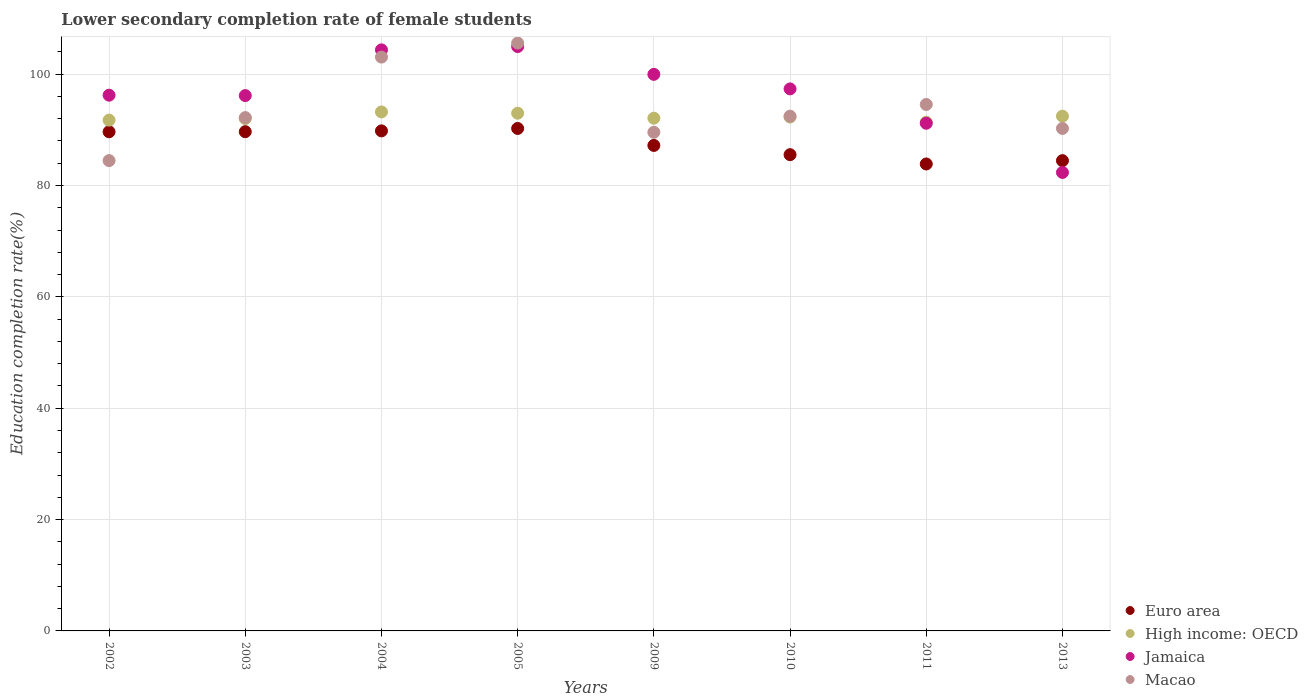How many different coloured dotlines are there?
Your response must be concise. 4. Is the number of dotlines equal to the number of legend labels?
Ensure brevity in your answer.  Yes. What is the lower secondary completion rate of female students in Macao in 2004?
Offer a very short reply. 103.06. Across all years, what is the maximum lower secondary completion rate of female students in Euro area?
Your response must be concise. 90.25. Across all years, what is the minimum lower secondary completion rate of female students in High income: OECD?
Your response must be concise. 91.37. In which year was the lower secondary completion rate of female students in Euro area minimum?
Offer a terse response. 2011. What is the total lower secondary completion rate of female students in High income: OECD in the graph?
Your answer should be very brief. 738.16. What is the difference between the lower secondary completion rate of female students in High income: OECD in 2003 and that in 2009?
Give a very brief answer. -0.07. What is the difference between the lower secondary completion rate of female students in Macao in 2003 and the lower secondary completion rate of female students in Euro area in 2005?
Your response must be concise. 1.95. What is the average lower secondary completion rate of female students in Macao per year?
Give a very brief answer. 94.01. In the year 2005, what is the difference between the lower secondary completion rate of female students in Jamaica and lower secondary completion rate of female students in High income: OECD?
Make the answer very short. 11.97. In how many years, is the lower secondary completion rate of female students in Macao greater than 64 %?
Offer a very short reply. 8. What is the ratio of the lower secondary completion rate of female students in Macao in 2002 to that in 2013?
Your answer should be very brief. 0.94. Is the lower secondary completion rate of female students in Macao in 2002 less than that in 2013?
Your answer should be compact. Yes. What is the difference between the highest and the second highest lower secondary completion rate of female students in Euro area?
Keep it short and to the point. 0.44. What is the difference between the highest and the lowest lower secondary completion rate of female students in Macao?
Ensure brevity in your answer.  21.11. In how many years, is the lower secondary completion rate of female students in Jamaica greater than the average lower secondary completion rate of female students in Jamaica taken over all years?
Make the answer very short. 4. Does the lower secondary completion rate of female students in High income: OECD monotonically increase over the years?
Offer a terse response. No. Is the lower secondary completion rate of female students in Euro area strictly less than the lower secondary completion rate of female students in Jamaica over the years?
Provide a short and direct response. No. What is the difference between two consecutive major ticks on the Y-axis?
Offer a very short reply. 20. Does the graph contain grids?
Give a very brief answer. Yes. What is the title of the graph?
Keep it short and to the point. Lower secondary completion rate of female students. Does "Argentina" appear as one of the legend labels in the graph?
Provide a short and direct response. No. What is the label or title of the X-axis?
Ensure brevity in your answer.  Years. What is the label or title of the Y-axis?
Give a very brief answer. Education completion rate(%). What is the Education completion rate(%) of Euro area in 2002?
Your response must be concise. 89.65. What is the Education completion rate(%) in High income: OECD in 2002?
Give a very brief answer. 91.74. What is the Education completion rate(%) of Jamaica in 2002?
Give a very brief answer. 96.22. What is the Education completion rate(%) in Macao in 2002?
Provide a short and direct response. 84.47. What is the Education completion rate(%) in Euro area in 2003?
Provide a succinct answer. 89.66. What is the Education completion rate(%) of High income: OECD in 2003?
Provide a short and direct response. 92.02. What is the Education completion rate(%) in Jamaica in 2003?
Offer a very short reply. 96.15. What is the Education completion rate(%) of Macao in 2003?
Make the answer very short. 92.19. What is the Education completion rate(%) in Euro area in 2004?
Your answer should be compact. 89.81. What is the Education completion rate(%) of High income: OECD in 2004?
Provide a short and direct response. 93.21. What is the Education completion rate(%) of Jamaica in 2004?
Your response must be concise. 104.36. What is the Education completion rate(%) of Macao in 2004?
Make the answer very short. 103.06. What is the Education completion rate(%) in Euro area in 2005?
Give a very brief answer. 90.25. What is the Education completion rate(%) of High income: OECD in 2005?
Keep it short and to the point. 92.98. What is the Education completion rate(%) of Jamaica in 2005?
Make the answer very short. 104.95. What is the Education completion rate(%) of Macao in 2005?
Your answer should be compact. 105.58. What is the Education completion rate(%) of Euro area in 2009?
Provide a succinct answer. 87.19. What is the Education completion rate(%) of High income: OECD in 2009?
Your answer should be very brief. 92.09. What is the Education completion rate(%) in Jamaica in 2009?
Make the answer very short. 99.96. What is the Education completion rate(%) of Macao in 2009?
Provide a short and direct response. 89.55. What is the Education completion rate(%) in Euro area in 2010?
Your answer should be very brief. 85.53. What is the Education completion rate(%) of High income: OECD in 2010?
Your response must be concise. 92.29. What is the Education completion rate(%) in Jamaica in 2010?
Your answer should be compact. 97.35. What is the Education completion rate(%) in Macao in 2010?
Your response must be concise. 92.45. What is the Education completion rate(%) in Euro area in 2011?
Your response must be concise. 83.87. What is the Education completion rate(%) of High income: OECD in 2011?
Your answer should be compact. 91.37. What is the Education completion rate(%) of Jamaica in 2011?
Give a very brief answer. 91.18. What is the Education completion rate(%) of Macao in 2011?
Your answer should be very brief. 94.55. What is the Education completion rate(%) in Euro area in 2013?
Your answer should be compact. 84.46. What is the Education completion rate(%) of High income: OECD in 2013?
Offer a very short reply. 92.45. What is the Education completion rate(%) of Jamaica in 2013?
Provide a succinct answer. 82.34. What is the Education completion rate(%) of Macao in 2013?
Offer a very short reply. 90.25. Across all years, what is the maximum Education completion rate(%) in Euro area?
Your response must be concise. 90.25. Across all years, what is the maximum Education completion rate(%) of High income: OECD?
Make the answer very short. 93.21. Across all years, what is the maximum Education completion rate(%) in Jamaica?
Make the answer very short. 104.95. Across all years, what is the maximum Education completion rate(%) in Macao?
Your response must be concise. 105.58. Across all years, what is the minimum Education completion rate(%) in Euro area?
Provide a short and direct response. 83.87. Across all years, what is the minimum Education completion rate(%) of High income: OECD?
Keep it short and to the point. 91.37. Across all years, what is the minimum Education completion rate(%) in Jamaica?
Your answer should be compact. 82.34. Across all years, what is the minimum Education completion rate(%) in Macao?
Make the answer very short. 84.47. What is the total Education completion rate(%) in Euro area in the graph?
Offer a terse response. 700.42. What is the total Education completion rate(%) of High income: OECD in the graph?
Offer a very short reply. 738.16. What is the total Education completion rate(%) in Jamaica in the graph?
Provide a succinct answer. 772.5. What is the total Education completion rate(%) of Macao in the graph?
Provide a short and direct response. 752.12. What is the difference between the Education completion rate(%) of Euro area in 2002 and that in 2003?
Ensure brevity in your answer.  -0.02. What is the difference between the Education completion rate(%) of High income: OECD in 2002 and that in 2003?
Offer a terse response. -0.28. What is the difference between the Education completion rate(%) in Jamaica in 2002 and that in 2003?
Offer a very short reply. 0.07. What is the difference between the Education completion rate(%) of Macao in 2002 and that in 2003?
Your answer should be very brief. -7.72. What is the difference between the Education completion rate(%) in Euro area in 2002 and that in 2004?
Make the answer very short. -0.16. What is the difference between the Education completion rate(%) of High income: OECD in 2002 and that in 2004?
Offer a very short reply. -1.47. What is the difference between the Education completion rate(%) in Jamaica in 2002 and that in 2004?
Your response must be concise. -8.14. What is the difference between the Education completion rate(%) of Macao in 2002 and that in 2004?
Ensure brevity in your answer.  -18.59. What is the difference between the Education completion rate(%) of Euro area in 2002 and that in 2005?
Your response must be concise. -0.6. What is the difference between the Education completion rate(%) in High income: OECD in 2002 and that in 2005?
Make the answer very short. -1.24. What is the difference between the Education completion rate(%) in Jamaica in 2002 and that in 2005?
Keep it short and to the point. -8.73. What is the difference between the Education completion rate(%) of Macao in 2002 and that in 2005?
Make the answer very short. -21.11. What is the difference between the Education completion rate(%) of Euro area in 2002 and that in 2009?
Give a very brief answer. 2.45. What is the difference between the Education completion rate(%) in High income: OECD in 2002 and that in 2009?
Offer a very short reply. -0.35. What is the difference between the Education completion rate(%) of Jamaica in 2002 and that in 2009?
Your response must be concise. -3.74. What is the difference between the Education completion rate(%) in Macao in 2002 and that in 2009?
Offer a very short reply. -5.08. What is the difference between the Education completion rate(%) of Euro area in 2002 and that in 2010?
Keep it short and to the point. 4.11. What is the difference between the Education completion rate(%) in High income: OECD in 2002 and that in 2010?
Ensure brevity in your answer.  -0.55. What is the difference between the Education completion rate(%) in Jamaica in 2002 and that in 2010?
Provide a succinct answer. -1.13. What is the difference between the Education completion rate(%) of Macao in 2002 and that in 2010?
Ensure brevity in your answer.  -7.98. What is the difference between the Education completion rate(%) in Euro area in 2002 and that in 2011?
Offer a terse response. 5.78. What is the difference between the Education completion rate(%) of High income: OECD in 2002 and that in 2011?
Your response must be concise. 0.37. What is the difference between the Education completion rate(%) in Jamaica in 2002 and that in 2011?
Your answer should be compact. 5.04. What is the difference between the Education completion rate(%) in Macao in 2002 and that in 2011?
Keep it short and to the point. -10.08. What is the difference between the Education completion rate(%) in Euro area in 2002 and that in 2013?
Provide a short and direct response. 5.19. What is the difference between the Education completion rate(%) of High income: OECD in 2002 and that in 2013?
Provide a succinct answer. -0.71. What is the difference between the Education completion rate(%) in Jamaica in 2002 and that in 2013?
Keep it short and to the point. 13.88. What is the difference between the Education completion rate(%) of Macao in 2002 and that in 2013?
Provide a succinct answer. -5.78. What is the difference between the Education completion rate(%) of Euro area in 2003 and that in 2004?
Offer a terse response. -0.14. What is the difference between the Education completion rate(%) in High income: OECD in 2003 and that in 2004?
Provide a short and direct response. -1.19. What is the difference between the Education completion rate(%) in Jamaica in 2003 and that in 2004?
Your answer should be compact. -8.21. What is the difference between the Education completion rate(%) of Macao in 2003 and that in 2004?
Offer a very short reply. -10.87. What is the difference between the Education completion rate(%) in Euro area in 2003 and that in 2005?
Give a very brief answer. -0.58. What is the difference between the Education completion rate(%) of High income: OECD in 2003 and that in 2005?
Ensure brevity in your answer.  -0.96. What is the difference between the Education completion rate(%) in Jamaica in 2003 and that in 2005?
Give a very brief answer. -8.8. What is the difference between the Education completion rate(%) in Macao in 2003 and that in 2005?
Ensure brevity in your answer.  -13.39. What is the difference between the Education completion rate(%) in Euro area in 2003 and that in 2009?
Your response must be concise. 2.47. What is the difference between the Education completion rate(%) in High income: OECD in 2003 and that in 2009?
Offer a terse response. -0.07. What is the difference between the Education completion rate(%) in Jamaica in 2003 and that in 2009?
Your answer should be compact. -3.81. What is the difference between the Education completion rate(%) of Macao in 2003 and that in 2009?
Ensure brevity in your answer.  2.64. What is the difference between the Education completion rate(%) in Euro area in 2003 and that in 2010?
Ensure brevity in your answer.  4.13. What is the difference between the Education completion rate(%) of High income: OECD in 2003 and that in 2010?
Provide a short and direct response. -0.27. What is the difference between the Education completion rate(%) of Jamaica in 2003 and that in 2010?
Provide a short and direct response. -1.2. What is the difference between the Education completion rate(%) in Macao in 2003 and that in 2010?
Give a very brief answer. -0.26. What is the difference between the Education completion rate(%) of Euro area in 2003 and that in 2011?
Your response must be concise. 5.8. What is the difference between the Education completion rate(%) of High income: OECD in 2003 and that in 2011?
Offer a very short reply. 0.65. What is the difference between the Education completion rate(%) in Jamaica in 2003 and that in 2011?
Your answer should be very brief. 4.97. What is the difference between the Education completion rate(%) of Macao in 2003 and that in 2011?
Your answer should be compact. -2.36. What is the difference between the Education completion rate(%) in Euro area in 2003 and that in 2013?
Provide a short and direct response. 5.2. What is the difference between the Education completion rate(%) in High income: OECD in 2003 and that in 2013?
Offer a very short reply. -0.43. What is the difference between the Education completion rate(%) of Jamaica in 2003 and that in 2013?
Provide a short and direct response. 13.8. What is the difference between the Education completion rate(%) in Macao in 2003 and that in 2013?
Provide a succinct answer. 1.95. What is the difference between the Education completion rate(%) in Euro area in 2004 and that in 2005?
Your answer should be very brief. -0.44. What is the difference between the Education completion rate(%) in High income: OECD in 2004 and that in 2005?
Your answer should be compact. 0.23. What is the difference between the Education completion rate(%) of Jamaica in 2004 and that in 2005?
Provide a succinct answer. -0.59. What is the difference between the Education completion rate(%) of Macao in 2004 and that in 2005?
Keep it short and to the point. -2.52. What is the difference between the Education completion rate(%) of Euro area in 2004 and that in 2009?
Offer a terse response. 2.61. What is the difference between the Education completion rate(%) in High income: OECD in 2004 and that in 2009?
Your answer should be very brief. 1.13. What is the difference between the Education completion rate(%) of Jamaica in 2004 and that in 2009?
Your answer should be compact. 4.4. What is the difference between the Education completion rate(%) of Macao in 2004 and that in 2009?
Your answer should be very brief. 13.51. What is the difference between the Education completion rate(%) of Euro area in 2004 and that in 2010?
Provide a short and direct response. 4.27. What is the difference between the Education completion rate(%) of High income: OECD in 2004 and that in 2010?
Ensure brevity in your answer.  0.92. What is the difference between the Education completion rate(%) of Jamaica in 2004 and that in 2010?
Your answer should be very brief. 7.01. What is the difference between the Education completion rate(%) in Macao in 2004 and that in 2010?
Your answer should be compact. 10.61. What is the difference between the Education completion rate(%) in Euro area in 2004 and that in 2011?
Offer a very short reply. 5.94. What is the difference between the Education completion rate(%) in High income: OECD in 2004 and that in 2011?
Ensure brevity in your answer.  1.84. What is the difference between the Education completion rate(%) of Jamaica in 2004 and that in 2011?
Offer a terse response. 13.18. What is the difference between the Education completion rate(%) in Macao in 2004 and that in 2011?
Offer a terse response. 8.51. What is the difference between the Education completion rate(%) in Euro area in 2004 and that in 2013?
Make the answer very short. 5.35. What is the difference between the Education completion rate(%) of High income: OECD in 2004 and that in 2013?
Your answer should be compact. 0.76. What is the difference between the Education completion rate(%) of Jamaica in 2004 and that in 2013?
Your answer should be compact. 22.01. What is the difference between the Education completion rate(%) in Macao in 2004 and that in 2013?
Provide a short and direct response. 12.82. What is the difference between the Education completion rate(%) of Euro area in 2005 and that in 2009?
Give a very brief answer. 3.05. What is the difference between the Education completion rate(%) in High income: OECD in 2005 and that in 2009?
Provide a succinct answer. 0.9. What is the difference between the Education completion rate(%) in Jamaica in 2005 and that in 2009?
Offer a terse response. 4.99. What is the difference between the Education completion rate(%) of Macao in 2005 and that in 2009?
Make the answer very short. 16.03. What is the difference between the Education completion rate(%) of Euro area in 2005 and that in 2010?
Offer a terse response. 4.71. What is the difference between the Education completion rate(%) of High income: OECD in 2005 and that in 2010?
Make the answer very short. 0.69. What is the difference between the Education completion rate(%) in Jamaica in 2005 and that in 2010?
Provide a succinct answer. 7.6. What is the difference between the Education completion rate(%) of Macao in 2005 and that in 2010?
Your answer should be very brief. 13.13. What is the difference between the Education completion rate(%) of Euro area in 2005 and that in 2011?
Ensure brevity in your answer.  6.38. What is the difference between the Education completion rate(%) in High income: OECD in 2005 and that in 2011?
Your answer should be compact. 1.61. What is the difference between the Education completion rate(%) in Jamaica in 2005 and that in 2011?
Keep it short and to the point. 13.77. What is the difference between the Education completion rate(%) in Macao in 2005 and that in 2011?
Ensure brevity in your answer.  11.03. What is the difference between the Education completion rate(%) in Euro area in 2005 and that in 2013?
Provide a succinct answer. 5.78. What is the difference between the Education completion rate(%) of High income: OECD in 2005 and that in 2013?
Provide a short and direct response. 0.53. What is the difference between the Education completion rate(%) in Jamaica in 2005 and that in 2013?
Keep it short and to the point. 22.61. What is the difference between the Education completion rate(%) of Macao in 2005 and that in 2013?
Ensure brevity in your answer.  15.34. What is the difference between the Education completion rate(%) in Euro area in 2009 and that in 2010?
Your answer should be compact. 1.66. What is the difference between the Education completion rate(%) in High income: OECD in 2009 and that in 2010?
Provide a succinct answer. -0.21. What is the difference between the Education completion rate(%) of Jamaica in 2009 and that in 2010?
Offer a very short reply. 2.61. What is the difference between the Education completion rate(%) in Macao in 2009 and that in 2010?
Ensure brevity in your answer.  -2.9. What is the difference between the Education completion rate(%) in Euro area in 2009 and that in 2011?
Offer a very short reply. 3.33. What is the difference between the Education completion rate(%) in High income: OECD in 2009 and that in 2011?
Make the answer very short. 0.72. What is the difference between the Education completion rate(%) of Jamaica in 2009 and that in 2011?
Provide a succinct answer. 8.78. What is the difference between the Education completion rate(%) of Macao in 2009 and that in 2011?
Your answer should be compact. -5. What is the difference between the Education completion rate(%) of Euro area in 2009 and that in 2013?
Your response must be concise. 2.73. What is the difference between the Education completion rate(%) of High income: OECD in 2009 and that in 2013?
Ensure brevity in your answer.  -0.36. What is the difference between the Education completion rate(%) in Jamaica in 2009 and that in 2013?
Your answer should be compact. 17.62. What is the difference between the Education completion rate(%) of Macao in 2009 and that in 2013?
Provide a short and direct response. -0.69. What is the difference between the Education completion rate(%) of Euro area in 2010 and that in 2011?
Ensure brevity in your answer.  1.67. What is the difference between the Education completion rate(%) of High income: OECD in 2010 and that in 2011?
Your response must be concise. 0.92. What is the difference between the Education completion rate(%) in Jamaica in 2010 and that in 2011?
Provide a short and direct response. 6.17. What is the difference between the Education completion rate(%) in Macao in 2010 and that in 2011?
Offer a very short reply. -2.1. What is the difference between the Education completion rate(%) in Euro area in 2010 and that in 2013?
Keep it short and to the point. 1.07. What is the difference between the Education completion rate(%) of High income: OECD in 2010 and that in 2013?
Offer a terse response. -0.16. What is the difference between the Education completion rate(%) in Jamaica in 2010 and that in 2013?
Your response must be concise. 15.01. What is the difference between the Education completion rate(%) in Macao in 2010 and that in 2013?
Offer a terse response. 2.21. What is the difference between the Education completion rate(%) of Euro area in 2011 and that in 2013?
Your response must be concise. -0.6. What is the difference between the Education completion rate(%) of High income: OECD in 2011 and that in 2013?
Ensure brevity in your answer.  -1.08. What is the difference between the Education completion rate(%) of Jamaica in 2011 and that in 2013?
Your answer should be very brief. 8.83. What is the difference between the Education completion rate(%) in Macao in 2011 and that in 2013?
Ensure brevity in your answer.  4.31. What is the difference between the Education completion rate(%) in Euro area in 2002 and the Education completion rate(%) in High income: OECD in 2003?
Offer a very short reply. -2.37. What is the difference between the Education completion rate(%) of Euro area in 2002 and the Education completion rate(%) of Jamaica in 2003?
Ensure brevity in your answer.  -6.5. What is the difference between the Education completion rate(%) of Euro area in 2002 and the Education completion rate(%) of Macao in 2003?
Keep it short and to the point. -2.55. What is the difference between the Education completion rate(%) of High income: OECD in 2002 and the Education completion rate(%) of Jamaica in 2003?
Your answer should be very brief. -4.41. What is the difference between the Education completion rate(%) in High income: OECD in 2002 and the Education completion rate(%) in Macao in 2003?
Offer a terse response. -0.45. What is the difference between the Education completion rate(%) in Jamaica in 2002 and the Education completion rate(%) in Macao in 2003?
Your answer should be compact. 4.02. What is the difference between the Education completion rate(%) of Euro area in 2002 and the Education completion rate(%) of High income: OECD in 2004?
Ensure brevity in your answer.  -3.57. What is the difference between the Education completion rate(%) of Euro area in 2002 and the Education completion rate(%) of Jamaica in 2004?
Provide a succinct answer. -14.71. What is the difference between the Education completion rate(%) in Euro area in 2002 and the Education completion rate(%) in Macao in 2004?
Your answer should be compact. -13.41. What is the difference between the Education completion rate(%) in High income: OECD in 2002 and the Education completion rate(%) in Jamaica in 2004?
Provide a short and direct response. -12.62. What is the difference between the Education completion rate(%) in High income: OECD in 2002 and the Education completion rate(%) in Macao in 2004?
Your answer should be compact. -11.32. What is the difference between the Education completion rate(%) of Jamaica in 2002 and the Education completion rate(%) of Macao in 2004?
Provide a short and direct response. -6.84. What is the difference between the Education completion rate(%) of Euro area in 2002 and the Education completion rate(%) of High income: OECD in 2005?
Ensure brevity in your answer.  -3.34. What is the difference between the Education completion rate(%) in Euro area in 2002 and the Education completion rate(%) in Jamaica in 2005?
Your answer should be very brief. -15.3. What is the difference between the Education completion rate(%) of Euro area in 2002 and the Education completion rate(%) of Macao in 2005?
Make the answer very short. -15.94. What is the difference between the Education completion rate(%) of High income: OECD in 2002 and the Education completion rate(%) of Jamaica in 2005?
Your answer should be compact. -13.21. What is the difference between the Education completion rate(%) in High income: OECD in 2002 and the Education completion rate(%) in Macao in 2005?
Your response must be concise. -13.84. What is the difference between the Education completion rate(%) in Jamaica in 2002 and the Education completion rate(%) in Macao in 2005?
Make the answer very short. -9.37. What is the difference between the Education completion rate(%) in Euro area in 2002 and the Education completion rate(%) in High income: OECD in 2009?
Your response must be concise. -2.44. What is the difference between the Education completion rate(%) in Euro area in 2002 and the Education completion rate(%) in Jamaica in 2009?
Offer a terse response. -10.31. What is the difference between the Education completion rate(%) of Euro area in 2002 and the Education completion rate(%) of Macao in 2009?
Your response must be concise. 0.09. What is the difference between the Education completion rate(%) of High income: OECD in 2002 and the Education completion rate(%) of Jamaica in 2009?
Keep it short and to the point. -8.22. What is the difference between the Education completion rate(%) in High income: OECD in 2002 and the Education completion rate(%) in Macao in 2009?
Ensure brevity in your answer.  2.19. What is the difference between the Education completion rate(%) in Jamaica in 2002 and the Education completion rate(%) in Macao in 2009?
Offer a terse response. 6.66. What is the difference between the Education completion rate(%) of Euro area in 2002 and the Education completion rate(%) of High income: OECD in 2010?
Provide a short and direct response. -2.65. What is the difference between the Education completion rate(%) in Euro area in 2002 and the Education completion rate(%) in Jamaica in 2010?
Ensure brevity in your answer.  -7.7. What is the difference between the Education completion rate(%) in Euro area in 2002 and the Education completion rate(%) in Macao in 2010?
Your response must be concise. -2.81. What is the difference between the Education completion rate(%) of High income: OECD in 2002 and the Education completion rate(%) of Jamaica in 2010?
Your answer should be compact. -5.61. What is the difference between the Education completion rate(%) of High income: OECD in 2002 and the Education completion rate(%) of Macao in 2010?
Ensure brevity in your answer.  -0.71. What is the difference between the Education completion rate(%) in Jamaica in 2002 and the Education completion rate(%) in Macao in 2010?
Offer a very short reply. 3.77. What is the difference between the Education completion rate(%) in Euro area in 2002 and the Education completion rate(%) in High income: OECD in 2011?
Provide a short and direct response. -1.72. What is the difference between the Education completion rate(%) of Euro area in 2002 and the Education completion rate(%) of Jamaica in 2011?
Your answer should be very brief. -1.53. What is the difference between the Education completion rate(%) of Euro area in 2002 and the Education completion rate(%) of Macao in 2011?
Provide a short and direct response. -4.9. What is the difference between the Education completion rate(%) in High income: OECD in 2002 and the Education completion rate(%) in Jamaica in 2011?
Provide a succinct answer. 0.56. What is the difference between the Education completion rate(%) in High income: OECD in 2002 and the Education completion rate(%) in Macao in 2011?
Your response must be concise. -2.81. What is the difference between the Education completion rate(%) of Jamaica in 2002 and the Education completion rate(%) of Macao in 2011?
Provide a short and direct response. 1.67. What is the difference between the Education completion rate(%) in Euro area in 2002 and the Education completion rate(%) in High income: OECD in 2013?
Provide a succinct answer. -2.8. What is the difference between the Education completion rate(%) in Euro area in 2002 and the Education completion rate(%) in Jamaica in 2013?
Offer a terse response. 7.3. What is the difference between the Education completion rate(%) in Euro area in 2002 and the Education completion rate(%) in Macao in 2013?
Give a very brief answer. -0.6. What is the difference between the Education completion rate(%) of High income: OECD in 2002 and the Education completion rate(%) of Jamaica in 2013?
Make the answer very short. 9.4. What is the difference between the Education completion rate(%) of High income: OECD in 2002 and the Education completion rate(%) of Macao in 2013?
Your response must be concise. 1.49. What is the difference between the Education completion rate(%) in Jamaica in 2002 and the Education completion rate(%) in Macao in 2013?
Offer a very short reply. 5.97. What is the difference between the Education completion rate(%) of Euro area in 2003 and the Education completion rate(%) of High income: OECD in 2004?
Your response must be concise. -3.55. What is the difference between the Education completion rate(%) in Euro area in 2003 and the Education completion rate(%) in Jamaica in 2004?
Give a very brief answer. -14.69. What is the difference between the Education completion rate(%) in Euro area in 2003 and the Education completion rate(%) in Macao in 2004?
Keep it short and to the point. -13.4. What is the difference between the Education completion rate(%) of High income: OECD in 2003 and the Education completion rate(%) of Jamaica in 2004?
Your answer should be compact. -12.34. What is the difference between the Education completion rate(%) of High income: OECD in 2003 and the Education completion rate(%) of Macao in 2004?
Your answer should be very brief. -11.04. What is the difference between the Education completion rate(%) of Jamaica in 2003 and the Education completion rate(%) of Macao in 2004?
Keep it short and to the point. -6.91. What is the difference between the Education completion rate(%) in Euro area in 2003 and the Education completion rate(%) in High income: OECD in 2005?
Make the answer very short. -3.32. What is the difference between the Education completion rate(%) of Euro area in 2003 and the Education completion rate(%) of Jamaica in 2005?
Keep it short and to the point. -15.29. What is the difference between the Education completion rate(%) in Euro area in 2003 and the Education completion rate(%) in Macao in 2005?
Offer a terse response. -15.92. What is the difference between the Education completion rate(%) in High income: OECD in 2003 and the Education completion rate(%) in Jamaica in 2005?
Offer a very short reply. -12.93. What is the difference between the Education completion rate(%) of High income: OECD in 2003 and the Education completion rate(%) of Macao in 2005?
Give a very brief answer. -13.56. What is the difference between the Education completion rate(%) in Jamaica in 2003 and the Education completion rate(%) in Macao in 2005?
Offer a very short reply. -9.44. What is the difference between the Education completion rate(%) in Euro area in 2003 and the Education completion rate(%) in High income: OECD in 2009?
Keep it short and to the point. -2.42. What is the difference between the Education completion rate(%) in Euro area in 2003 and the Education completion rate(%) in Jamaica in 2009?
Give a very brief answer. -10.3. What is the difference between the Education completion rate(%) in Euro area in 2003 and the Education completion rate(%) in Macao in 2009?
Ensure brevity in your answer.  0.11. What is the difference between the Education completion rate(%) of High income: OECD in 2003 and the Education completion rate(%) of Jamaica in 2009?
Provide a succinct answer. -7.94. What is the difference between the Education completion rate(%) in High income: OECD in 2003 and the Education completion rate(%) in Macao in 2009?
Provide a succinct answer. 2.47. What is the difference between the Education completion rate(%) in Jamaica in 2003 and the Education completion rate(%) in Macao in 2009?
Make the answer very short. 6.59. What is the difference between the Education completion rate(%) of Euro area in 2003 and the Education completion rate(%) of High income: OECD in 2010?
Your answer should be very brief. -2.63. What is the difference between the Education completion rate(%) in Euro area in 2003 and the Education completion rate(%) in Jamaica in 2010?
Ensure brevity in your answer.  -7.69. What is the difference between the Education completion rate(%) of Euro area in 2003 and the Education completion rate(%) of Macao in 2010?
Your answer should be very brief. -2.79. What is the difference between the Education completion rate(%) of High income: OECD in 2003 and the Education completion rate(%) of Jamaica in 2010?
Provide a short and direct response. -5.33. What is the difference between the Education completion rate(%) of High income: OECD in 2003 and the Education completion rate(%) of Macao in 2010?
Your answer should be compact. -0.43. What is the difference between the Education completion rate(%) of Jamaica in 2003 and the Education completion rate(%) of Macao in 2010?
Provide a short and direct response. 3.69. What is the difference between the Education completion rate(%) of Euro area in 2003 and the Education completion rate(%) of High income: OECD in 2011?
Keep it short and to the point. -1.71. What is the difference between the Education completion rate(%) of Euro area in 2003 and the Education completion rate(%) of Jamaica in 2011?
Offer a terse response. -1.51. What is the difference between the Education completion rate(%) in Euro area in 2003 and the Education completion rate(%) in Macao in 2011?
Give a very brief answer. -4.89. What is the difference between the Education completion rate(%) of High income: OECD in 2003 and the Education completion rate(%) of Jamaica in 2011?
Keep it short and to the point. 0.84. What is the difference between the Education completion rate(%) of High income: OECD in 2003 and the Education completion rate(%) of Macao in 2011?
Keep it short and to the point. -2.53. What is the difference between the Education completion rate(%) of Jamaica in 2003 and the Education completion rate(%) of Macao in 2011?
Your response must be concise. 1.59. What is the difference between the Education completion rate(%) in Euro area in 2003 and the Education completion rate(%) in High income: OECD in 2013?
Offer a very short reply. -2.79. What is the difference between the Education completion rate(%) in Euro area in 2003 and the Education completion rate(%) in Jamaica in 2013?
Provide a succinct answer. 7.32. What is the difference between the Education completion rate(%) in Euro area in 2003 and the Education completion rate(%) in Macao in 2013?
Your answer should be very brief. -0.58. What is the difference between the Education completion rate(%) of High income: OECD in 2003 and the Education completion rate(%) of Jamaica in 2013?
Ensure brevity in your answer.  9.68. What is the difference between the Education completion rate(%) of High income: OECD in 2003 and the Education completion rate(%) of Macao in 2013?
Your response must be concise. 1.77. What is the difference between the Education completion rate(%) of Jamaica in 2003 and the Education completion rate(%) of Macao in 2013?
Provide a short and direct response. 5.9. What is the difference between the Education completion rate(%) of Euro area in 2004 and the Education completion rate(%) of High income: OECD in 2005?
Give a very brief answer. -3.18. What is the difference between the Education completion rate(%) in Euro area in 2004 and the Education completion rate(%) in Jamaica in 2005?
Offer a very short reply. -15.14. What is the difference between the Education completion rate(%) of Euro area in 2004 and the Education completion rate(%) of Macao in 2005?
Offer a terse response. -15.78. What is the difference between the Education completion rate(%) of High income: OECD in 2004 and the Education completion rate(%) of Jamaica in 2005?
Make the answer very short. -11.74. What is the difference between the Education completion rate(%) in High income: OECD in 2004 and the Education completion rate(%) in Macao in 2005?
Ensure brevity in your answer.  -12.37. What is the difference between the Education completion rate(%) of Jamaica in 2004 and the Education completion rate(%) of Macao in 2005?
Offer a very short reply. -1.23. What is the difference between the Education completion rate(%) of Euro area in 2004 and the Education completion rate(%) of High income: OECD in 2009?
Give a very brief answer. -2.28. What is the difference between the Education completion rate(%) of Euro area in 2004 and the Education completion rate(%) of Jamaica in 2009?
Your answer should be compact. -10.15. What is the difference between the Education completion rate(%) of Euro area in 2004 and the Education completion rate(%) of Macao in 2009?
Offer a very short reply. 0.25. What is the difference between the Education completion rate(%) of High income: OECD in 2004 and the Education completion rate(%) of Jamaica in 2009?
Ensure brevity in your answer.  -6.75. What is the difference between the Education completion rate(%) in High income: OECD in 2004 and the Education completion rate(%) in Macao in 2009?
Your response must be concise. 3.66. What is the difference between the Education completion rate(%) in Jamaica in 2004 and the Education completion rate(%) in Macao in 2009?
Your answer should be compact. 14.8. What is the difference between the Education completion rate(%) in Euro area in 2004 and the Education completion rate(%) in High income: OECD in 2010?
Make the answer very short. -2.48. What is the difference between the Education completion rate(%) of Euro area in 2004 and the Education completion rate(%) of Jamaica in 2010?
Your response must be concise. -7.54. What is the difference between the Education completion rate(%) in Euro area in 2004 and the Education completion rate(%) in Macao in 2010?
Offer a terse response. -2.64. What is the difference between the Education completion rate(%) of High income: OECD in 2004 and the Education completion rate(%) of Jamaica in 2010?
Offer a terse response. -4.14. What is the difference between the Education completion rate(%) of High income: OECD in 2004 and the Education completion rate(%) of Macao in 2010?
Provide a short and direct response. 0.76. What is the difference between the Education completion rate(%) of Jamaica in 2004 and the Education completion rate(%) of Macao in 2010?
Your answer should be compact. 11.9. What is the difference between the Education completion rate(%) of Euro area in 2004 and the Education completion rate(%) of High income: OECD in 2011?
Your answer should be very brief. -1.56. What is the difference between the Education completion rate(%) of Euro area in 2004 and the Education completion rate(%) of Jamaica in 2011?
Your response must be concise. -1.37. What is the difference between the Education completion rate(%) in Euro area in 2004 and the Education completion rate(%) in Macao in 2011?
Keep it short and to the point. -4.74. What is the difference between the Education completion rate(%) of High income: OECD in 2004 and the Education completion rate(%) of Jamaica in 2011?
Keep it short and to the point. 2.04. What is the difference between the Education completion rate(%) of High income: OECD in 2004 and the Education completion rate(%) of Macao in 2011?
Ensure brevity in your answer.  -1.34. What is the difference between the Education completion rate(%) in Jamaica in 2004 and the Education completion rate(%) in Macao in 2011?
Provide a succinct answer. 9.8. What is the difference between the Education completion rate(%) of Euro area in 2004 and the Education completion rate(%) of High income: OECD in 2013?
Provide a short and direct response. -2.64. What is the difference between the Education completion rate(%) of Euro area in 2004 and the Education completion rate(%) of Jamaica in 2013?
Your answer should be very brief. 7.47. What is the difference between the Education completion rate(%) in Euro area in 2004 and the Education completion rate(%) in Macao in 2013?
Offer a very short reply. -0.44. What is the difference between the Education completion rate(%) of High income: OECD in 2004 and the Education completion rate(%) of Jamaica in 2013?
Provide a short and direct response. 10.87. What is the difference between the Education completion rate(%) in High income: OECD in 2004 and the Education completion rate(%) in Macao in 2013?
Your response must be concise. 2.97. What is the difference between the Education completion rate(%) of Jamaica in 2004 and the Education completion rate(%) of Macao in 2013?
Offer a terse response. 14.11. What is the difference between the Education completion rate(%) in Euro area in 2005 and the Education completion rate(%) in High income: OECD in 2009?
Make the answer very short. -1.84. What is the difference between the Education completion rate(%) in Euro area in 2005 and the Education completion rate(%) in Jamaica in 2009?
Provide a succinct answer. -9.71. What is the difference between the Education completion rate(%) in Euro area in 2005 and the Education completion rate(%) in Macao in 2009?
Give a very brief answer. 0.69. What is the difference between the Education completion rate(%) in High income: OECD in 2005 and the Education completion rate(%) in Jamaica in 2009?
Provide a succinct answer. -6.98. What is the difference between the Education completion rate(%) in High income: OECD in 2005 and the Education completion rate(%) in Macao in 2009?
Your answer should be compact. 3.43. What is the difference between the Education completion rate(%) in Jamaica in 2005 and the Education completion rate(%) in Macao in 2009?
Make the answer very short. 15.4. What is the difference between the Education completion rate(%) of Euro area in 2005 and the Education completion rate(%) of High income: OECD in 2010?
Give a very brief answer. -2.05. What is the difference between the Education completion rate(%) in Euro area in 2005 and the Education completion rate(%) in Jamaica in 2010?
Offer a terse response. -7.1. What is the difference between the Education completion rate(%) of Euro area in 2005 and the Education completion rate(%) of Macao in 2010?
Your answer should be compact. -2.21. What is the difference between the Education completion rate(%) in High income: OECD in 2005 and the Education completion rate(%) in Jamaica in 2010?
Ensure brevity in your answer.  -4.37. What is the difference between the Education completion rate(%) of High income: OECD in 2005 and the Education completion rate(%) of Macao in 2010?
Make the answer very short. 0.53. What is the difference between the Education completion rate(%) in Jamaica in 2005 and the Education completion rate(%) in Macao in 2010?
Ensure brevity in your answer.  12.5. What is the difference between the Education completion rate(%) of Euro area in 2005 and the Education completion rate(%) of High income: OECD in 2011?
Make the answer very short. -1.13. What is the difference between the Education completion rate(%) of Euro area in 2005 and the Education completion rate(%) of Jamaica in 2011?
Keep it short and to the point. -0.93. What is the difference between the Education completion rate(%) of Euro area in 2005 and the Education completion rate(%) of Macao in 2011?
Keep it short and to the point. -4.31. What is the difference between the Education completion rate(%) in High income: OECD in 2005 and the Education completion rate(%) in Jamaica in 2011?
Your response must be concise. 1.81. What is the difference between the Education completion rate(%) in High income: OECD in 2005 and the Education completion rate(%) in Macao in 2011?
Provide a short and direct response. -1.57. What is the difference between the Education completion rate(%) in Jamaica in 2005 and the Education completion rate(%) in Macao in 2011?
Keep it short and to the point. 10.4. What is the difference between the Education completion rate(%) in Euro area in 2005 and the Education completion rate(%) in High income: OECD in 2013?
Give a very brief answer. -2.2. What is the difference between the Education completion rate(%) of Euro area in 2005 and the Education completion rate(%) of Jamaica in 2013?
Provide a short and direct response. 7.9. What is the difference between the Education completion rate(%) of Euro area in 2005 and the Education completion rate(%) of Macao in 2013?
Your response must be concise. -0. What is the difference between the Education completion rate(%) of High income: OECD in 2005 and the Education completion rate(%) of Jamaica in 2013?
Offer a terse response. 10.64. What is the difference between the Education completion rate(%) in High income: OECD in 2005 and the Education completion rate(%) in Macao in 2013?
Your response must be concise. 2.74. What is the difference between the Education completion rate(%) in Jamaica in 2005 and the Education completion rate(%) in Macao in 2013?
Your answer should be very brief. 14.7. What is the difference between the Education completion rate(%) of Euro area in 2009 and the Education completion rate(%) of High income: OECD in 2010?
Offer a very short reply. -5.1. What is the difference between the Education completion rate(%) in Euro area in 2009 and the Education completion rate(%) in Jamaica in 2010?
Your response must be concise. -10.16. What is the difference between the Education completion rate(%) in Euro area in 2009 and the Education completion rate(%) in Macao in 2010?
Give a very brief answer. -5.26. What is the difference between the Education completion rate(%) in High income: OECD in 2009 and the Education completion rate(%) in Jamaica in 2010?
Ensure brevity in your answer.  -5.26. What is the difference between the Education completion rate(%) in High income: OECD in 2009 and the Education completion rate(%) in Macao in 2010?
Give a very brief answer. -0.37. What is the difference between the Education completion rate(%) of Jamaica in 2009 and the Education completion rate(%) of Macao in 2010?
Provide a short and direct response. 7.51. What is the difference between the Education completion rate(%) of Euro area in 2009 and the Education completion rate(%) of High income: OECD in 2011?
Your answer should be very brief. -4.18. What is the difference between the Education completion rate(%) of Euro area in 2009 and the Education completion rate(%) of Jamaica in 2011?
Offer a very short reply. -3.98. What is the difference between the Education completion rate(%) of Euro area in 2009 and the Education completion rate(%) of Macao in 2011?
Your answer should be compact. -7.36. What is the difference between the Education completion rate(%) of High income: OECD in 2009 and the Education completion rate(%) of Jamaica in 2011?
Ensure brevity in your answer.  0.91. What is the difference between the Education completion rate(%) in High income: OECD in 2009 and the Education completion rate(%) in Macao in 2011?
Make the answer very short. -2.47. What is the difference between the Education completion rate(%) of Jamaica in 2009 and the Education completion rate(%) of Macao in 2011?
Ensure brevity in your answer.  5.41. What is the difference between the Education completion rate(%) of Euro area in 2009 and the Education completion rate(%) of High income: OECD in 2013?
Offer a very short reply. -5.26. What is the difference between the Education completion rate(%) in Euro area in 2009 and the Education completion rate(%) in Jamaica in 2013?
Offer a terse response. 4.85. What is the difference between the Education completion rate(%) of Euro area in 2009 and the Education completion rate(%) of Macao in 2013?
Provide a short and direct response. -3.05. What is the difference between the Education completion rate(%) of High income: OECD in 2009 and the Education completion rate(%) of Jamaica in 2013?
Give a very brief answer. 9.74. What is the difference between the Education completion rate(%) of High income: OECD in 2009 and the Education completion rate(%) of Macao in 2013?
Your answer should be very brief. 1.84. What is the difference between the Education completion rate(%) of Jamaica in 2009 and the Education completion rate(%) of Macao in 2013?
Give a very brief answer. 9.71. What is the difference between the Education completion rate(%) in Euro area in 2010 and the Education completion rate(%) in High income: OECD in 2011?
Keep it short and to the point. -5.84. What is the difference between the Education completion rate(%) of Euro area in 2010 and the Education completion rate(%) of Jamaica in 2011?
Make the answer very short. -5.64. What is the difference between the Education completion rate(%) in Euro area in 2010 and the Education completion rate(%) in Macao in 2011?
Keep it short and to the point. -9.02. What is the difference between the Education completion rate(%) of High income: OECD in 2010 and the Education completion rate(%) of Jamaica in 2011?
Ensure brevity in your answer.  1.12. What is the difference between the Education completion rate(%) of High income: OECD in 2010 and the Education completion rate(%) of Macao in 2011?
Your answer should be very brief. -2.26. What is the difference between the Education completion rate(%) of Jamaica in 2010 and the Education completion rate(%) of Macao in 2011?
Your answer should be very brief. 2.8. What is the difference between the Education completion rate(%) in Euro area in 2010 and the Education completion rate(%) in High income: OECD in 2013?
Provide a succinct answer. -6.92. What is the difference between the Education completion rate(%) of Euro area in 2010 and the Education completion rate(%) of Jamaica in 2013?
Offer a terse response. 3.19. What is the difference between the Education completion rate(%) in Euro area in 2010 and the Education completion rate(%) in Macao in 2013?
Your answer should be very brief. -4.71. What is the difference between the Education completion rate(%) in High income: OECD in 2010 and the Education completion rate(%) in Jamaica in 2013?
Keep it short and to the point. 9.95. What is the difference between the Education completion rate(%) in High income: OECD in 2010 and the Education completion rate(%) in Macao in 2013?
Ensure brevity in your answer.  2.05. What is the difference between the Education completion rate(%) in Jamaica in 2010 and the Education completion rate(%) in Macao in 2013?
Provide a short and direct response. 7.1. What is the difference between the Education completion rate(%) in Euro area in 2011 and the Education completion rate(%) in High income: OECD in 2013?
Your response must be concise. -8.58. What is the difference between the Education completion rate(%) in Euro area in 2011 and the Education completion rate(%) in Jamaica in 2013?
Your answer should be compact. 1.52. What is the difference between the Education completion rate(%) of Euro area in 2011 and the Education completion rate(%) of Macao in 2013?
Offer a very short reply. -6.38. What is the difference between the Education completion rate(%) of High income: OECD in 2011 and the Education completion rate(%) of Jamaica in 2013?
Provide a short and direct response. 9.03. What is the difference between the Education completion rate(%) of High income: OECD in 2011 and the Education completion rate(%) of Macao in 2013?
Your response must be concise. 1.12. What is the difference between the Education completion rate(%) in Jamaica in 2011 and the Education completion rate(%) in Macao in 2013?
Your response must be concise. 0.93. What is the average Education completion rate(%) of Euro area per year?
Your answer should be compact. 87.55. What is the average Education completion rate(%) in High income: OECD per year?
Make the answer very short. 92.27. What is the average Education completion rate(%) in Jamaica per year?
Offer a very short reply. 96.56. What is the average Education completion rate(%) of Macao per year?
Offer a very short reply. 94.01. In the year 2002, what is the difference between the Education completion rate(%) in Euro area and Education completion rate(%) in High income: OECD?
Offer a terse response. -2.09. In the year 2002, what is the difference between the Education completion rate(%) in Euro area and Education completion rate(%) in Jamaica?
Give a very brief answer. -6.57. In the year 2002, what is the difference between the Education completion rate(%) of Euro area and Education completion rate(%) of Macao?
Provide a short and direct response. 5.18. In the year 2002, what is the difference between the Education completion rate(%) of High income: OECD and Education completion rate(%) of Jamaica?
Provide a succinct answer. -4.48. In the year 2002, what is the difference between the Education completion rate(%) in High income: OECD and Education completion rate(%) in Macao?
Keep it short and to the point. 7.27. In the year 2002, what is the difference between the Education completion rate(%) of Jamaica and Education completion rate(%) of Macao?
Your answer should be very brief. 11.75. In the year 2003, what is the difference between the Education completion rate(%) of Euro area and Education completion rate(%) of High income: OECD?
Your response must be concise. -2.36. In the year 2003, what is the difference between the Education completion rate(%) of Euro area and Education completion rate(%) of Jamaica?
Make the answer very short. -6.48. In the year 2003, what is the difference between the Education completion rate(%) in Euro area and Education completion rate(%) in Macao?
Offer a terse response. -2.53. In the year 2003, what is the difference between the Education completion rate(%) in High income: OECD and Education completion rate(%) in Jamaica?
Provide a succinct answer. -4.13. In the year 2003, what is the difference between the Education completion rate(%) in High income: OECD and Education completion rate(%) in Macao?
Offer a very short reply. -0.17. In the year 2003, what is the difference between the Education completion rate(%) of Jamaica and Education completion rate(%) of Macao?
Give a very brief answer. 3.95. In the year 2004, what is the difference between the Education completion rate(%) in Euro area and Education completion rate(%) in High income: OECD?
Ensure brevity in your answer.  -3.4. In the year 2004, what is the difference between the Education completion rate(%) in Euro area and Education completion rate(%) in Jamaica?
Your answer should be compact. -14.55. In the year 2004, what is the difference between the Education completion rate(%) in Euro area and Education completion rate(%) in Macao?
Ensure brevity in your answer.  -13.25. In the year 2004, what is the difference between the Education completion rate(%) in High income: OECD and Education completion rate(%) in Jamaica?
Provide a short and direct response. -11.14. In the year 2004, what is the difference between the Education completion rate(%) in High income: OECD and Education completion rate(%) in Macao?
Ensure brevity in your answer.  -9.85. In the year 2004, what is the difference between the Education completion rate(%) of Jamaica and Education completion rate(%) of Macao?
Offer a very short reply. 1.3. In the year 2005, what is the difference between the Education completion rate(%) in Euro area and Education completion rate(%) in High income: OECD?
Offer a terse response. -2.74. In the year 2005, what is the difference between the Education completion rate(%) of Euro area and Education completion rate(%) of Jamaica?
Provide a succinct answer. -14.71. In the year 2005, what is the difference between the Education completion rate(%) in Euro area and Education completion rate(%) in Macao?
Keep it short and to the point. -15.34. In the year 2005, what is the difference between the Education completion rate(%) of High income: OECD and Education completion rate(%) of Jamaica?
Offer a terse response. -11.97. In the year 2005, what is the difference between the Education completion rate(%) of High income: OECD and Education completion rate(%) of Macao?
Provide a succinct answer. -12.6. In the year 2005, what is the difference between the Education completion rate(%) in Jamaica and Education completion rate(%) in Macao?
Make the answer very short. -0.63. In the year 2009, what is the difference between the Education completion rate(%) in Euro area and Education completion rate(%) in High income: OECD?
Keep it short and to the point. -4.89. In the year 2009, what is the difference between the Education completion rate(%) in Euro area and Education completion rate(%) in Jamaica?
Provide a succinct answer. -12.77. In the year 2009, what is the difference between the Education completion rate(%) in Euro area and Education completion rate(%) in Macao?
Provide a short and direct response. -2.36. In the year 2009, what is the difference between the Education completion rate(%) of High income: OECD and Education completion rate(%) of Jamaica?
Ensure brevity in your answer.  -7.87. In the year 2009, what is the difference between the Education completion rate(%) of High income: OECD and Education completion rate(%) of Macao?
Provide a short and direct response. 2.53. In the year 2009, what is the difference between the Education completion rate(%) of Jamaica and Education completion rate(%) of Macao?
Your answer should be compact. 10.41. In the year 2010, what is the difference between the Education completion rate(%) of Euro area and Education completion rate(%) of High income: OECD?
Keep it short and to the point. -6.76. In the year 2010, what is the difference between the Education completion rate(%) of Euro area and Education completion rate(%) of Jamaica?
Your answer should be very brief. -11.82. In the year 2010, what is the difference between the Education completion rate(%) of Euro area and Education completion rate(%) of Macao?
Keep it short and to the point. -6.92. In the year 2010, what is the difference between the Education completion rate(%) in High income: OECD and Education completion rate(%) in Jamaica?
Your response must be concise. -5.06. In the year 2010, what is the difference between the Education completion rate(%) of High income: OECD and Education completion rate(%) of Macao?
Keep it short and to the point. -0.16. In the year 2010, what is the difference between the Education completion rate(%) of Jamaica and Education completion rate(%) of Macao?
Offer a terse response. 4.9. In the year 2011, what is the difference between the Education completion rate(%) of Euro area and Education completion rate(%) of High income: OECD?
Ensure brevity in your answer.  -7.51. In the year 2011, what is the difference between the Education completion rate(%) of Euro area and Education completion rate(%) of Jamaica?
Make the answer very short. -7.31. In the year 2011, what is the difference between the Education completion rate(%) in Euro area and Education completion rate(%) in Macao?
Keep it short and to the point. -10.69. In the year 2011, what is the difference between the Education completion rate(%) in High income: OECD and Education completion rate(%) in Jamaica?
Give a very brief answer. 0.19. In the year 2011, what is the difference between the Education completion rate(%) in High income: OECD and Education completion rate(%) in Macao?
Provide a short and direct response. -3.18. In the year 2011, what is the difference between the Education completion rate(%) in Jamaica and Education completion rate(%) in Macao?
Make the answer very short. -3.38. In the year 2013, what is the difference between the Education completion rate(%) in Euro area and Education completion rate(%) in High income: OECD?
Offer a very short reply. -7.99. In the year 2013, what is the difference between the Education completion rate(%) in Euro area and Education completion rate(%) in Jamaica?
Give a very brief answer. 2.12. In the year 2013, what is the difference between the Education completion rate(%) of Euro area and Education completion rate(%) of Macao?
Provide a short and direct response. -5.78. In the year 2013, what is the difference between the Education completion rate(%) of High income: OECD and Education completion rate(%) of Jamaica?
Ensure brevity in your answer.  10.11. In the year 2013, what is the difference between the Education completion rate(%) of High income: OECD and Education completion rate(%) of Macao?
Provide a short and direct response. 2.2. In the year 2013, what is the difference between the Education completion rate(%) of Jamaica and Education completion rate(%) of Macao?
Your answer should be very brief. -7.9. What is the ratio of the Education completion rate(%) in Euro area in 2002 to that in 2003?
Make the answer very short. 1. What is the ratio of the Education completion rate(%) in High income: OECD in 2002 to that in 2003?
Offer a terse response. 1. What is the ratio of the Education completion rate(%) in Macao in 2002 to that in 2003?
Your answer should be compact. 0.92. What is the ratio of the Education completion rate(%) in High income: OECD in 2002 to that in 2004?
Offer a very short reply. 0.98. What is the ratio of the Education completion rate(%) in Jamaica in 2002 to that in 2004?
Your response must be concise. 0.92. What is the ratio of the Education completion rate(%) in Macao in 2002 to that in 2004?
Your answer should be very brief. 0.82. What is the ratio of the Education completion rate(%) in High income: OECD in 2002 to that in 2005?
Provide a short and direct response. 0.99. What is the ratio of the Education completion rate(%) of Jamaica in 2002 to that in 2005?
Ensure brevity in your answer.  0.92. What is the ratio of the Education completion rate(%) in Macao in 2002 to that in 2005?
Your response must be concise. 0.8. What is the ratio of the Education completion rate(%) of Euro area in 2002 to that in 2009?
Your answer should be compact. 1.03. What is the ratio of the Education completion rate(%) of High income: OECD in 2002 to that in 2009?
Keep it short and to the point. 1. What is the ratio of the Education completion rate(%) in Jamaica in 2002 to that in 2009?
Provide a succinct answer. 0.96. What is the ratio of the Education completion rate(%) of Macao in 2002 to that in 2009?
Your answer should be very brief. 0.94. What is the ratio of the Education completion rate(%) in Euro area in 2002 to that in 2010?
Offer a terse response. 1.05. What is the ratio of the Education completion rate(%) of Jamaica in 2002 to that in 2010?
Make the answer very short. 0.99. What is the ratio of the Education completion rate(%) in Macao in 2002 to that in 2010?
Provide a short and direct response. 0.91. What is the ratio of the Education completion rate(%) in Euro area in 2002 to that in 2011?
Make the answer very short. 1.07. What is the ratio of the Education completion rate(%) of High income: OECD in 2002 to that in 2011?
Ensure brevity in your answer.  1. What is the ratio of the Education completion rate(%) of Jamaica in 2002 to that in 2011?
Offer a very short reply. 1.06. What is the ratio of the Education completion rate(%) in Macao in 2002 to that in 2011?
Offer a terse response. 0.89. What is the ratio of the Education completion rate(%) in Euro area in 2002 to that in 2013?
Provide a succinct answer. 1.06. What is the ratio of the Education completion rate(%) of Jamaica in 2002 to that in 2013?
Keep it short and to the point. 1.17. What is the ratio of the Education completion rate(%) in Macao in 2002 to that in 2013?
Make the answer very short. 0.94. What is the ratio of the Education completion rate(%) in Euro area in 2003 to that in 2004?
Your answer should be compact. 1. What is the ratio of the Education completion rate(%) of High income: OECD in 2003 to that in 2004?
Your response must be concise. 0.99. What is the ratio of the Education completion rate(%) in Jamaica in 2003 to that in 2004?
Make the answer very short. 0.92. What is the ratio of the Education completion rate(%) in Macao in 2003 to that in 2004?
Provide a succinct answer. 0.89. What is the ratio of the Education completion rate(%) in Euro area in 2003 to that in 2005?
Provide a short and direct response. 0.99. What is the ratio of the Education completion rate(%) of High income: OECD in 2003 to that in 2005?
Offer a very short reply. 0.99. What is the ratio of the Education completion rate(%) of Jamaica in 2003 to that in 2005?
Your answer should be very brief. 0.92. What is the ratio of the Education completion rate(%) of Macao in 2003 to that in 2005?
Make the answer very short. 0.87. What is the ratio of the Education completion rate(%) in Euro area in 2003 to that in 2009?
Your response must be concise. 1.03. What is the ratio of the Education completion rate(%) of High income: OECD in 2003 to that in 2009?
Ensure brevity in your answer.  1. What is the ratio of the Education completion rate(%) in Jamaica in 2003 to that in 2009?
Provide a short and direct response. 0.96. What is the ratio of the Education completion rate(%) in Macao in 2003 to that in 2009?
Keep it short and to the point. 1.03. What is the ratio of the Education completion rate(%) of Euro area in 2003 to that in 2010?
Your response must be concise. 1.05. What is the ratio of the Education completion rate(%) in High income: OECD in 2003 to that in 2010?
Ensure brevity in your answer.  1. What is the ratio of the Education completion rate(%) of Jamaica in 2003 to that in 2010?
Ensure brevity in your answer.  0.99. What is the ratio of the Education completion rate(%) of Euro area in 2003 to that in 2011?
Your answer should be very brief. 1.07. What is the ratio of the Education completion rate(%) of High income: OECD in 2003 to that in 2011?
Offer a terse response. 1.01. What is the ratio of the Education completion rate(%) of Jamaica in 2003 to that in 2011?
Ensure brevity in your answer.  1.05. What is the ratio of the Education completion rate(%) of Macao in 2003 to that in 2011?
Offer a very short reply. 0.98. What is the ratio of the Education completion rate(%) of Euro area in 2003 to that in 2013?
Provide a short and direct response. 1.06. What is the ratio of the Education completion rate(%) of Jamaica in 2003 to that in 2013?
Make the answer very short. 1.17. What is the ratio of the Education completion rate(%) in Macao in 2003 to that in 2013?
Keep it short and to the point. 1.02. What is the ratio of the Education completion rate(%) of Jamaica in 2004 to that in 2005?
Your answer should be very brief. 0.99. What is the ratio of the Education completion rate(%) in Macao in 2004 to that in 2005?
Keep it short and to the point. 0.98. What is the ratio of the Education completion rate(%) in Euro area in 2004 to that in 2009?
Provide a succinct answer. 1.03. What is the ratio of the Education completion rate(%) in High income: OECD in 2004 to that in 2009?
Provide a short and direct response. 1.01. What is the ratio of the Education completion rate(%) in Jamaica in 2004 to that in 2009?
Your response must be concise. 1.04. What is the ratio of the Education completion rate(%) in Macao in 2004 to that in 2009?
Your answer should be compact. 1.15. What is the ratio of the Education completion rate(%) in Euro area in 2004 to that in 2010?
Offer a very short reply. 1.05. What is the ratio of the Education completion rate(%) of Jamaica in 2004 to that in 2010?
Keep it short and to the point. 1.07. What is the ratio of the Education completion rate(%) of Macao in 2004 to that in 2010?
Ensure brevity in your answer.  1.11. What is the ratio of the Education completion rate(%) of Euro area in 2004 to that in 2011?
Keep it short and to the point. 1.07. What is the ratio of the Education completion rate(%) in High income: OECD in 2004 to that in 2011?
Ensure brevity in your answer.  1.02. What is the ratio of the Education completion rate(%) of Jamaica in 2004 to that in 2011?
Your response must be concise. 1.14. What is the ratio of the Education completion rate(%) of Macao in 2004 to that in 2011?
Ensure brevity in your answer.  1.09. What is the ratio of the Education completion rate(%) of Euro area in 2004 to that in 2013?
Keep it short and to the point. 1.06. What is the ratio of the Education completion rate(%) in High income: OECD in 2004 to that in 2013?
Offer a very short reply. 1.01. What is the ratio of the Education completion rate(%) of Jamaica in 2004 to that in 2013?
Your response must be concise. 1.27. What is the ratio of the Education completion rate(%) of Macao in 2004 to that in 2013?
Provide a short and direct response. 1.14. What is the ratio of the Education completion rate(%) of Euro area in 2005 to that in 2009?
Your answer should be very brief. 1.03. What is the ratio of the Education completion rate(%) of High income: OECD in 2005 to that in 2009?
Keep it short and to the point. 1.01. What is the ratio of the Education completion rate(%) of Jamaica in 2005 to that in 2009?
Keep it short and to the point. 1.05. What is the ratio of the Education completion rate(%) of Macao in 2005 to that in 2009?
Provide a succinct answer. 1.18. What is the ratio of the Education completion rate(%) in Euro area in 2005 to that in 2010?
Keep it short and to the point. 1.06. What is the ratio of the Education completion rate(%) of High income: OECD in 2005 to that in 2010?
Offer a terse response. 1.01. What is the ratio of the Education completion rate(%) of Jamaica in 2005 to that in 2010?
Offer a very short reply. 1.08. What is the ratio of the Education completion rate(%) in Macao in 2005 to that in 2010?
Keep it short and to the point. 1.14. What is the ratio of the Education completion rate(%) in Euro area in 2005 to that in 2011?
Your answer should be compact. 1.08. What is the ratio of the Education completion rate(%) of High income: OECD in 2005 to that in 2011?
Ensure brevity in your answer.  1.02. What is the ratio of the Education completion rate(%) of Jamaica in 2005 to that in 2011?
Your answer should be very brief. 1.15. What is the ratio of the Education completion rate(%) of Macao in 2005 to that in 2011?
Offer a very short reply. 1.12. What is the ratio of the Education completion rate(%) of Euro area in 2005 to that in 2013?
Your answer should be compact. 1.07. What is the ratio of the Education completion rate(%) in High income: OECD in 2005 to that in 2013?
Offer a terse response. 1.01. What is the ratio of the Education completion rate(%) in Jamaica in 2005 to that in 2013?
Ensure brevity in your answer.  1.27. What is the ratio of the Education completion rate(%) in Macao in 2005 to that in 2013?
Give a very brief answer. 1.17. What is the ratio of the Education completion rate(%) of Euro area in 2009 to that in 2010?
Make the answer very short. 1.02. What is the ratio of the Education completion rate(%) in High income: OECD in 2009 to that in 2010?
Your answer should be very brief. 1. What is the ratio of the Education completion rate(%) in Jamaica in 2009 to that in 2010?
Provide a succinct answer. 1.03. What is the ratio of the Education completion rate(%) in Macao in 2009 to that in 2010?
Your answer should be very brief. 0.97. What is the ratio of the Education completion rate(%) of Euro area in 2009 to that in 2011?
Give a very brief answer. 1.04. What is the ratio of the Education completion rate(%) in Jamaica in 2009 to that in 2011?
Give a very brief answer. 1.1. What is the ratio of the Education completion rate(%) in Macao in 2009 to that in 2011?
Keep it short and to the point. 0.95. What is the ratio of the Education completion rate(%) of Euro area in 2009 to that in 2013?
Provide a short and direct response. 1.03. What is the ratio of the Education completion rate(%) in High income: OECD in 2009 to that in 2013?
Your response must be concise. 1. What is the ratio of the Education completion rate(%) in Jamaica in 2009 to that in 2013?
Your response must be concise. 1.21. What is the ratio of the Education completion rate(%) in Euro area in 2010 to that in 2011?
Offer a very short reply. 1.02. What is the ratio of the Education completion rate(%) in High income: OECD in 2010 to that in 2011?
Give a very brief answer. 1.01. What is the ratio of the Education completion rate(%) in Jamaica in 2010 to that in 2011?
Keep it short and to the point. 1.07. What is the ratio of the Education completion rate(%) of Macao in 2010 to that in 2011?
Your answer should be compact. 0.98. What is the ratio of the Education completion rate(%) in Euro area in 2010 to that in 2013?
Provide a succinct answer. 1.01. What is the ratio of the Education completion rate(%) in High income: OECD in 2010 to that in 2013?
Your answer should be very brief. 1. What is the ratio of the Education completion rate(%) of Jamaica in 2010 to that in 2013?
Make the answer very short. 1.18. What is the ratio of the Education completion rate(%) of Macao in 2010 to that in 2013?
Offer a terse response. 1.02. What is the ratio of the Education completion rate(%) of Euro area in 2011 to that in 2013?
Your response must be concise. 0.99. What is the ratio of the Education completion rate(%) of High income: OECD in 2011 to that in 2013?
Make the answer very short. 0.99. What is the ratio of the Education completion rate(%) in Jamaica in 2011 to that in 2013?
Your response must be concise. 1.11. What is the ratio of the Education completion rate(%) of Macao in 2011 to that in 2013?
Keep it short and to the point. 1.05. What is the difference between the highest and the second highest Education completion rate(%) in Euro area?
Give a very brief answer. 0.44. What is the difference between the highest and the second highest Education completion rate(%) in High income: OECD?
Your response must be concise. 0.23. What is the difference between the highest and the second highest Education completion rate(%) of Jamaica?
Keep it short and to the point. 0.59. What is the difference between the highest and the second highest Education completion rate(%) in Macao?
Your answer should be compact. 2.52. What is the difference between the highest and the lowest Education completion rate(%) of Euro area?
Keep it short and to the point. 6.38. What is the difference between the highest and the lowest Education completion rate(%) in High income: OECD?
Give a very brief answer. 1.84. What is the difference between the highest and the lowest Education completion rate(%) of Jamaica?
Offer a very short reply. 22.61. What is the difference between the highest and the lowest Education completion rate(%) in Macao?
Make the answer very short. 21.11. 